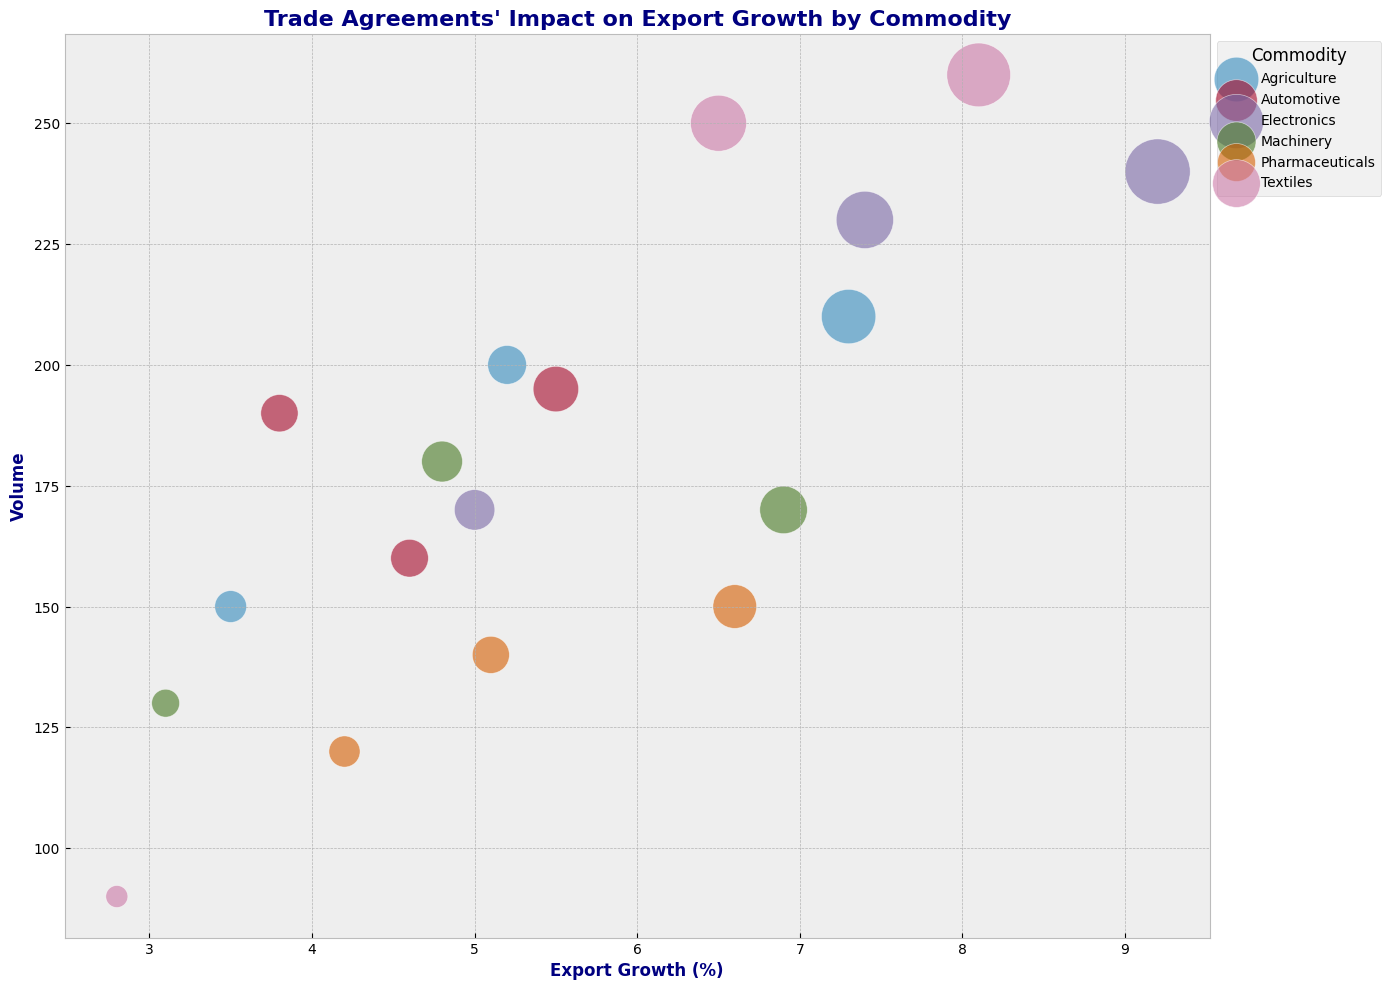Which commodity under the TPP has the highest export growth? Look at the data points where the Trade Agreement is TPP and find the one with the highest Export Growth value.
Answer: Electronics What is the average impact score of Electronics under all trade agreements? Find the Impact_Score for Electronics under all trade agreements (1702, 850, 2208), sum them up (4760), and divide by the number of agreements (3).
Answer: 1586.67 Under NAFTA, which commodity has the lowest export growth and what is its value? Identify the data points where the Trade Agreement is NAFTA and find the one with the lowest Export Growth value.
Answer: Automotive, 3.8% How does the export growth of Pharmaceuticals under the EU-Canada CETA agreement compare to that under NAFTA? Compare the Export Growth values for Pharmaceuticals under the EU-Canada CETA (4.2) and NAFTA (5.1)
Answer: Higher under NAFTA, 5.1% Which commodity has the largest volume under the TPP and what is its value? For the data points where the Trade Agreement is TPP, find the one with the highest Volume.
Answer: Textiles, 260 What is the difference in export growth between Textiles and Automotives under the TPP? Compare the Export Growth values for Textiles (8.1) and Automotives (5.5) under the TPP and find the difference.
Answer: 2.6% Which commodity under the EU-Canada CETA agreement has the highest impact score? Examine the Impact_Score values for commodities under the EU-Canada CETA and find the highest one.
Answer: Electronics What is the sum of the volumes for all commodities under NAFTA? Sum up the Volume values for all commodities under the NAFTA agreement (200, 180, 250, 230, 190, 140).
Answer: 1190 Compare the bubble sizes between Agriculture and Machinery under the TPP. Which is larger? Compare the Impact_Score for Agriculture (1533) and Machinery (1173) under the TPP.
Answer: Agriculture How does the export growth of Electronics under the EU-Canada CETA agreement compare to that of Textiles under the same agreement? Compare the Export Growth values for Electronics (5.0) and Textiles (2.8) under EU-Canada CETA.
Answer: Higher for Electronics, 5.0% 